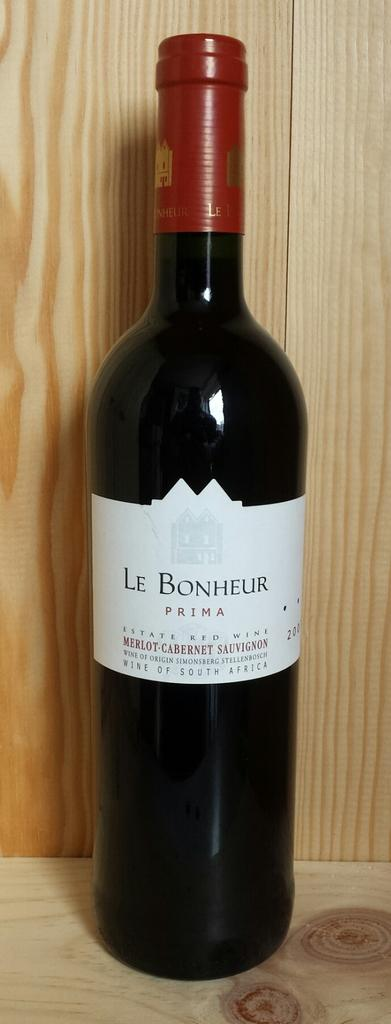<image>
Summarize the visual content of the image. A bottle of Le Bonheur Prima Estate Red Wine 